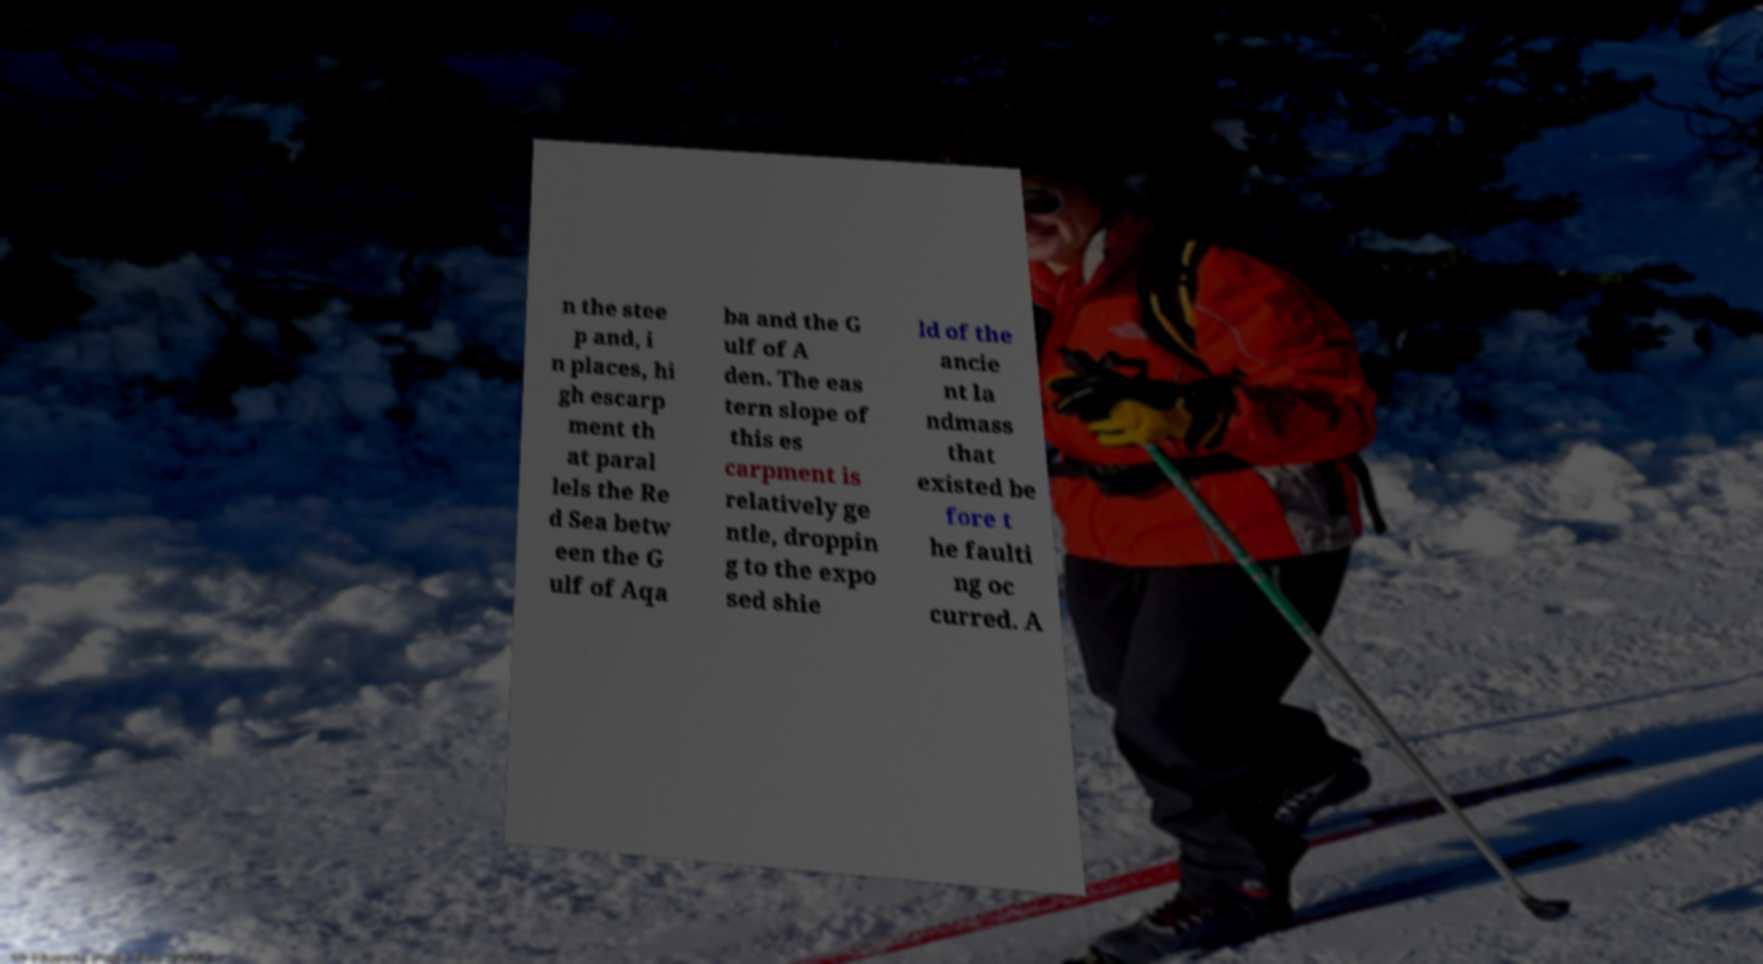Could you extract and type out the text from this image? n the stee p and, i n places, hi gh escarp ment th at paral lels the Re d Sea betw een the G ulf of Aqa ba and the G ulf of A den. The eas tern slope of this es carpment is relatively ge ntle, droppin g to the expo sed shie ld of the ancie nt la ndmass that existed be fore t he faulti ng oc curred. A 